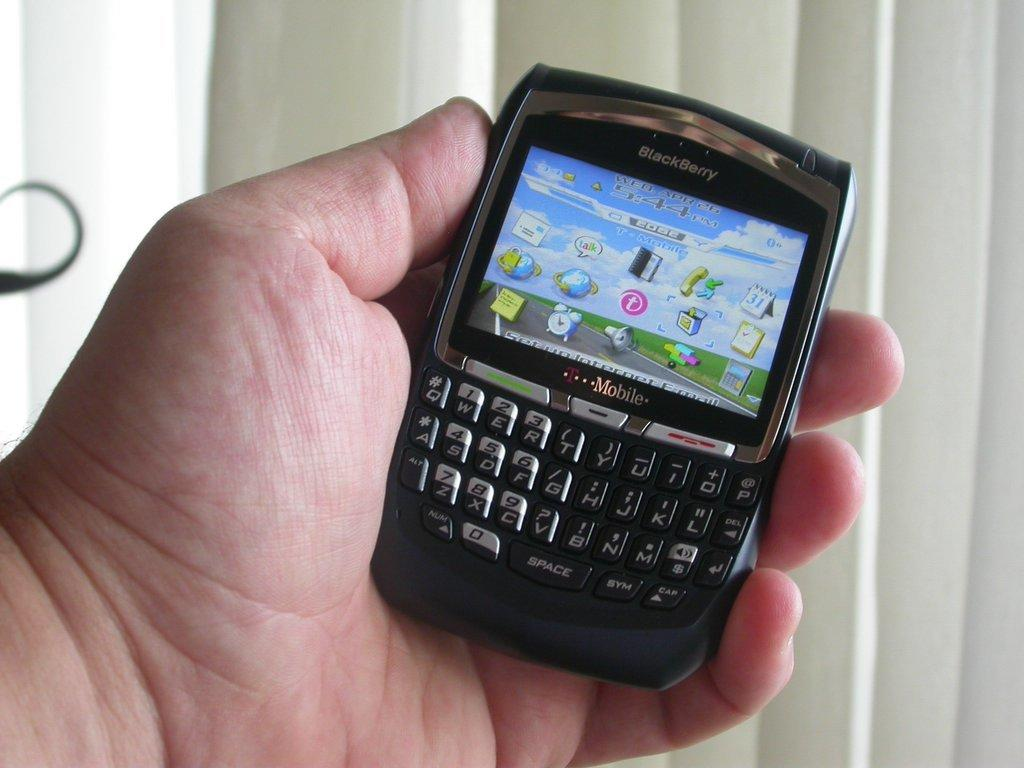What is being held in the person's hand in the image? There is a person's hand holding a mobile in the image. What can be seen in the background of the image? There are curtains in the background of the image. What type of weather can be seen in the image? There is no indication of weather in the image, as it only shows a person's hand holding a mobile and curtains in the background. 